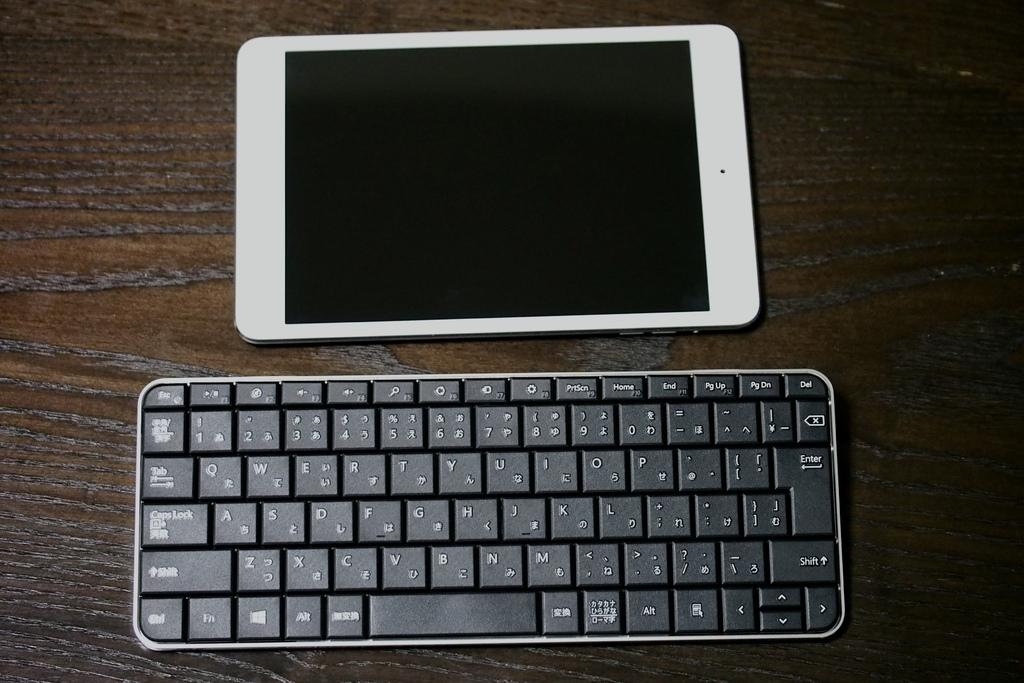What electronic device is visible in the image? There is an iPad in the image. What is placed next to the iPad in the image? There is a keyboard in the image. What color is the surface on which the iPad and keyboard are placed? The surface is brown in color. What type of cracker is being used as a bookmark for the iPad in the image? There is no cracker present in the image, and the iPad is not being used as a book. 